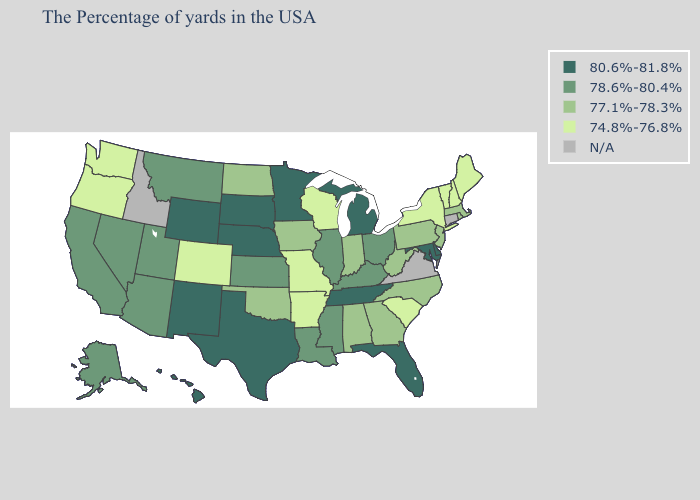Does the map have missing data?
Keep it brief. Yes. What is the highest value in the South ?
Give a very brief answer. 80.6%-81.8%. Does the first symbol in the legend represent the smallest category?
Answer briefly. No. What is the highest value in the USA?
Quick response, please. 80.6%-81.8%. What is the value of Maryland?
Concise answer only. 80.6%-81.8%. What is the value of Idaho?
Quick response, please. N/A. Name the states that have a value in the range 74.8%-76.8%?
Answer briefly. Maine, New Hampshire, Vermont, New York, South Carolina, Wisconsin, Missouri, Arkansas, Colorado, Washington, Oregon. Does Indiana have the highest value in the USA?
Short answer required. No. Name the states that have a value in the range 78.6%-80.4%?
Quick response, please. Ohio, Kentucky, Illinois, Mississippi, Louisiana, Kansas, Utah, Montana, Arizona, Nevada, California, Alaska. What is the lowest value in states that border Texas?
Write a very short answer. 74.8%-76.8%. What is the value of Wisconsin?
Give a very brief answer. 74.8%-76.8%. Among the states that border Tennessee , which have the lowest value?
Write a very short answer. Missouri, Arkansas. What is the lowest value in the West?
Give a very brief answer. 74.8%-76.8%. 